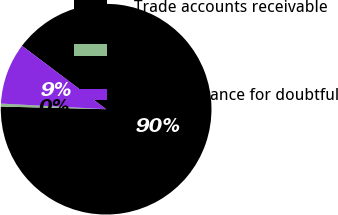Convert chart. <chart><loc_0><loc_0><loc_500><loc_500><pie_chart><fcel>Trade accounts receivable<fcel>Other<fcel>Less allowance for doubtful<nl><fcel>90.13%<fcel>0.45%<fcel>9.42%<nl></chart> 